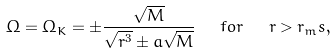<formula> <loc_0><loc_0><loc_500><loc_500>\Omega = \Omega _ { K } = \pm \frac { \sqrt { M } } { \sqrt { r ^ { 3 } } \pm a \sqrt { M } } \ \ f o r \ \ r > r _ { m } s ,</formula> 